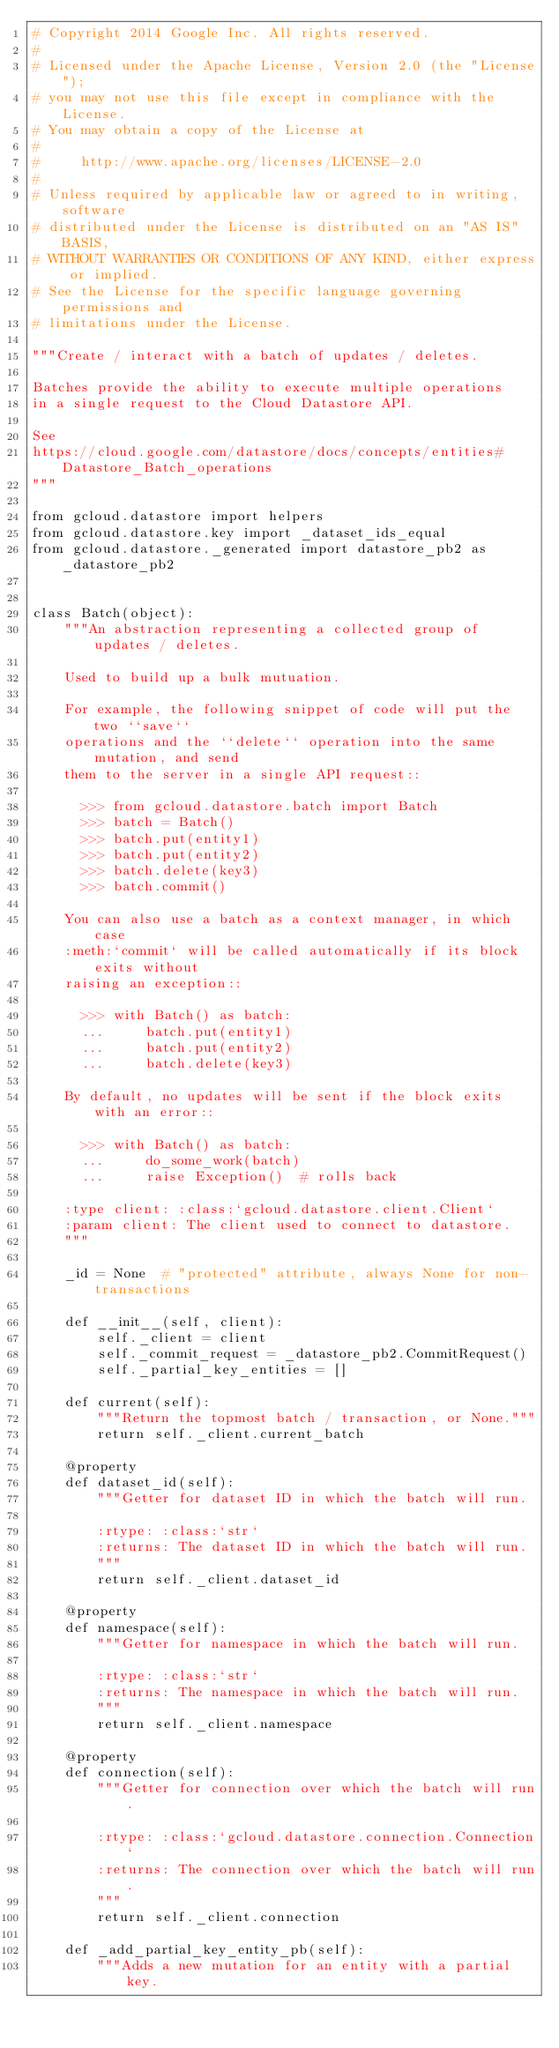<code> <loc_0><loc_0><loc_500><loc_500><_Python_># Copyright 2014 Google Inc. All rights reserved.
#
# Licensed under the Apache License, Version 2.0 (the "License");
# you may not use this file except in compliance with the License.
# You may obtain a copy of the License at
#
#     http://www.apache.org/licenses/LICENSE-2.0
#
# Unless required by applicable law or agreed to in writing, software
# distributed under the License is distributed on an "AS IS" BASIS,
# WITHOUT WARRANTIES OR CONDITIONS OF ANY KIND, either express or implied.
# See the License for the specific language governing permissions and
# limitations under the License.

"""Create / interact with a batch of updates / deletes.

Batches provide the ability to execute multiple operations
in a single request to the Cloud Datastore API.

See
https://cloud.google.com/datastore/docs/concepts/entities#Datastore_Batch_operations
"""

from gcloud.datastore import helpers
from gcloud.datastore.key import _dataset_ids_equal
from gcloud.datastore._generated import datastore_pb2 as _datastore_pb2


class Batch(object):
    """An abstraction representing a collected group of updates / deletes.

    Used to build up a bulk mutuation.

    For example, the following snippet of code will put the two ``save``
    operations and the ``delete`` operation into the same mutation, and send
    them to the server in a single API request::

      >>> from gcloud.datastore.batch import Batch
      >>> batch = Batch()
      >>> batch.put(entity1)
      >>> batch.put(entity2)
      >>> batch.delete(key3)
      >>> batch.commit()

    You can also use a batch as a context manager, in which case
    :meth:`commit` will be called automatically if its block exits without
    raising an exception::

      >>> with Batch() as batch:
      ...     batch.put(entity1)
      ...     batch.put(entity2)
      ...     batch.delete(key3)

    By default, no updates will be sent if the block exits with an error::

      >>> with Batch() as batch:
      ...     do_some_work(batch)
      ...     raise Exception()  # rolls back

    :type client: :class:`gcloud.datastore.client.Client`
    :param client: The client used to connect to datastore.
    """

    _id = None  # "protected" attribute, always None for non-transactions

    def __init__(self, client):
        self._client = client
        self._commit_request = _datastore_pb2.CommitRequest()
        self._partial_key_entities = []

    def current(self):
        """Return the topmost batch / transaction, or None."""
        return self._client.current_batch

    @property
    def dataset_id(self):
        """Getter for dataset ID in which the batch will run.

        :rtype: :class:`str`
        :returns: The dataset ID in which the batch will run.
        """
        return self._client.dataset_id

    @property
    def namespace(self):
        """Getter for namespace in which the batch will run.

        :rtype: :class:`str`
        :returns: The namespace in which the batch will run.
        """
        return self._client.namespace

    @property
    def connection(self):
        """Getter for connection over which the batch will run.

        :rtype: :class:`gcloud.datastore.connection.Connection`
        :returns: The connection over which the batch will run.
        """
        return self._client.connection

    def _add_partial_key_entity_pb(self):
        """Adds a new mutation for an entity with a partial key.
</code> 